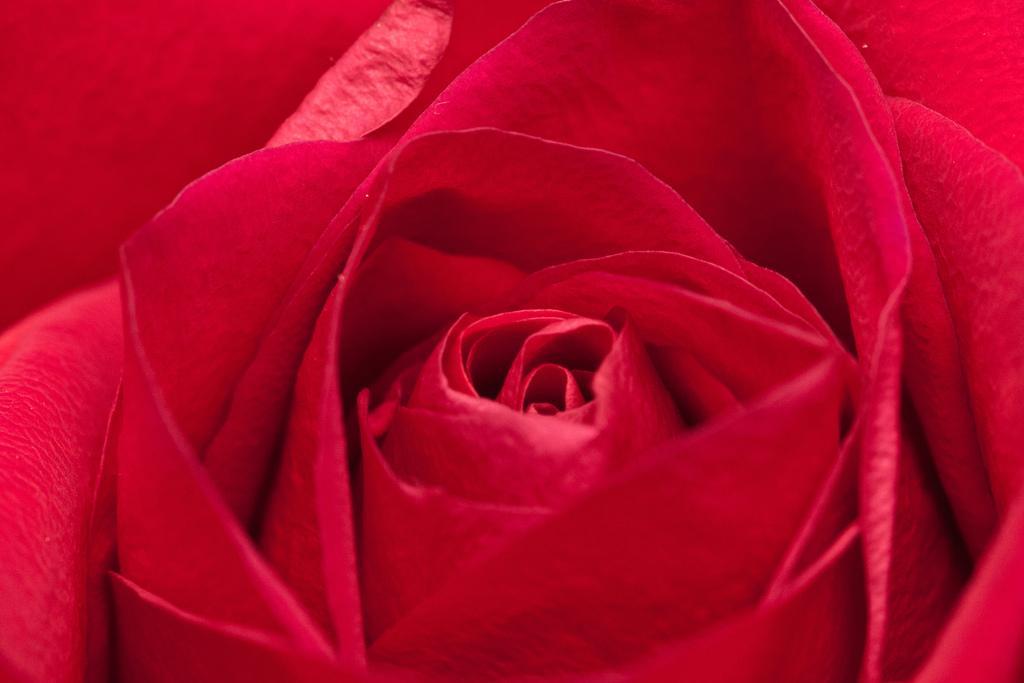Can you describe this image briefly? The image contain a red color flower which have many plates. 